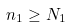Convert formula to latex. <formula><loc_0><loc_0><loc_500><loc_500>n _ { 1 } \geq N _ { 1 }</formula> 